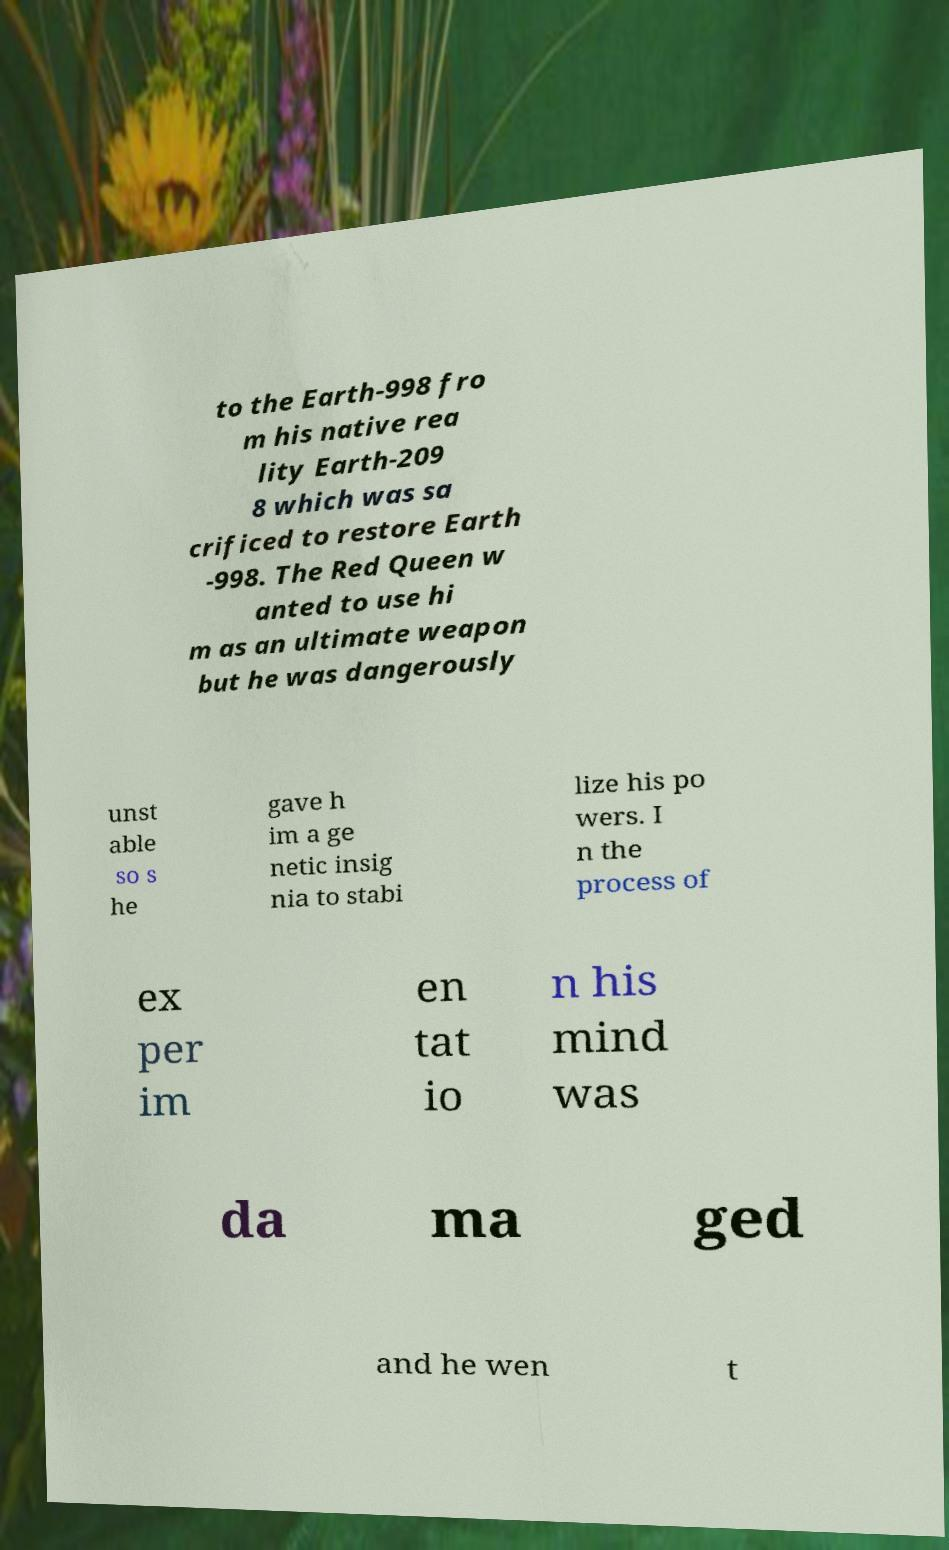What messages or text are displayed in this image? I need them in a readable, typed format. to the Earth-998 fro m his native rea lity Earth-209 8 which was sa crificed to restore Earth -998. The Red Queen w anted to use hi m as an ultimate weapon but he was dangerously unst able so s he gave h im a ge netic insig nia to stabi lize his po wers. I n the process of ex per im en tat io n his mind was da ma ged and he wen t 